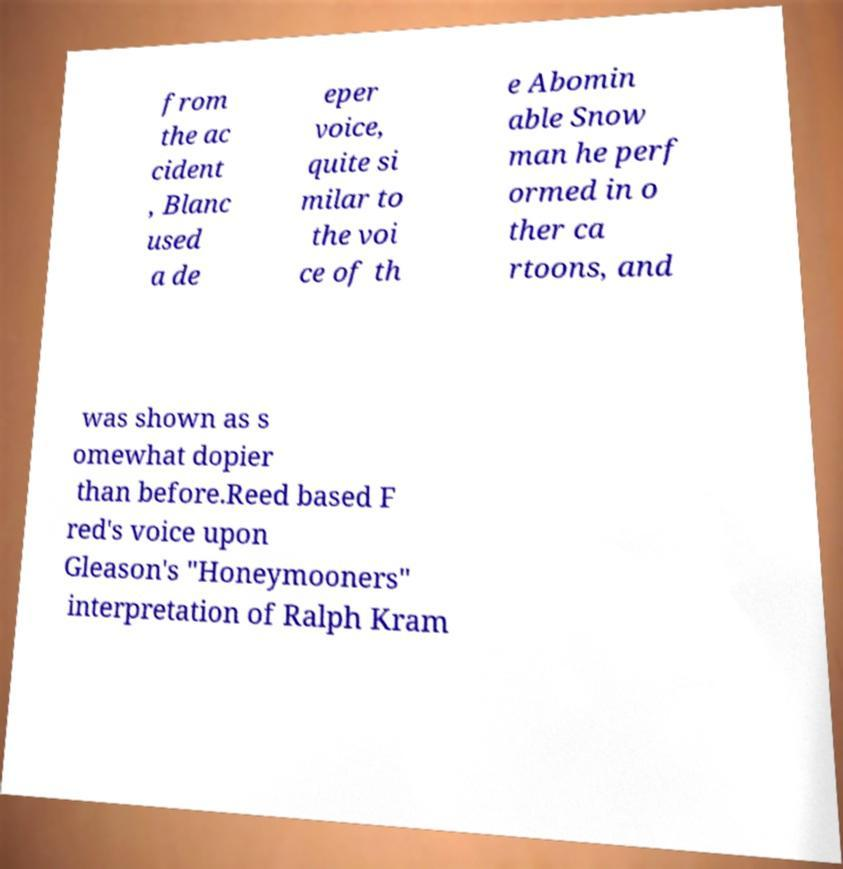For documentation purposes, I need the text within this image transcribed. Could you provide that? from the ac cident , Blanc used a de eper voice, quite si milar to the voi ce of th e Abomin able Snow man he perf ormed in o ther ca rtoons, and was shown as s omewhat dopier than before.Reed based F red's voice upon Gleason's "Honeymooners" interpretation of Ralph Kram 